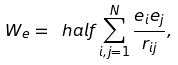Convert formula to latex. <formula><loc_0><loc_0><loc_500><loc_500>W _ { e } = \ h a l f \sum _ { i , j = 1 } ^ { N } \frac { e _ { i } e _ { j } } { r _ { i j } } ,</formula> 